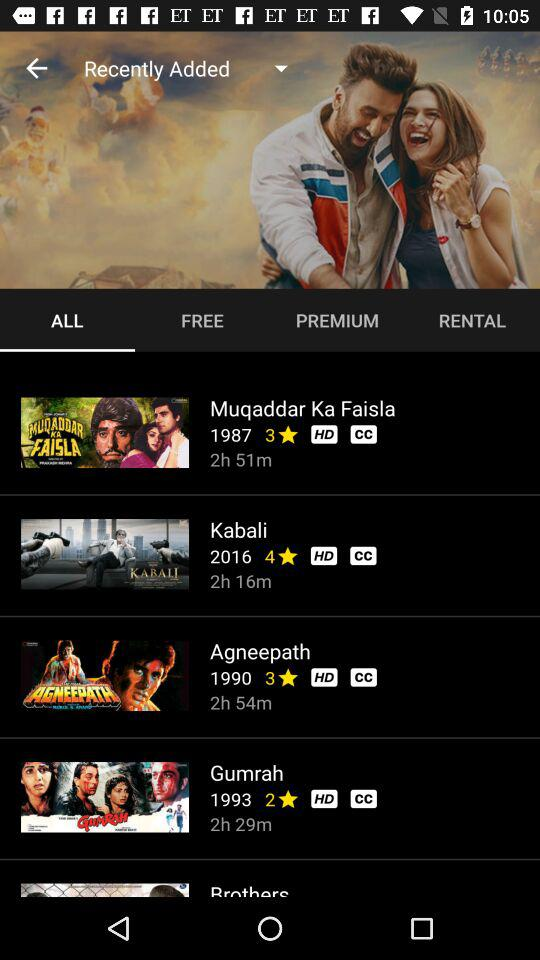What is the duration of the movie "Agneepath"? The duration of the movie "Agneepath" is 2 hour 54 minutes. 